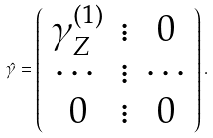<formula> <loc_0><loc_0><loc_500><loc_500>\hat { \gamma } = \left ( \begin{array} { c c c } \gamma _ { Z } ^ { ( 1 ) } & \vdots & 0 \\ \cdots & \vdots & \cdots \\ 0 & \vdots & 0 \\ \end{array} \right ) .</formula> 